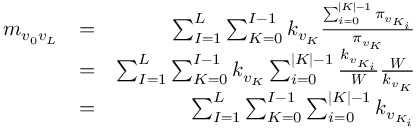<formula> <loc_0><loc_0><loc_500><loc_500>\begin{array} { r l r } { m _ { v _ { 0 } v _ { L } } } & { = } & { \sum _ { I = 1 } ^ { L } \sum _ { K = 0 } ^ { I - 1 } k _ { v _ { K } } \frac { \sum _ { i = 0 } ^ { | K | - 1 } \pi _ { v _ { K _ { i } } } } { \pi _ { v _ { K } } } } \\ & { = } & { \sum _ { I = 1 } ^ { L } \sum _ { K = 0 } ^ { I - 1 } k _ { v _ { K } } \sum _ { i = 0 } ^ { | K | - 1 } \frac { k _ { v _ { K _ { i } } } } { W } \frac { W } { k _ { v _ { K } } } } \\ & { = } & { \sum _ { I = 1 } ^ { L } \sum _ { K = 0 } ^ { I - 1 } \sum _ { i = 0 } ^ { | K | - 1 } k _ { v _ { K _ { i } } } } \end{array}</formula> 